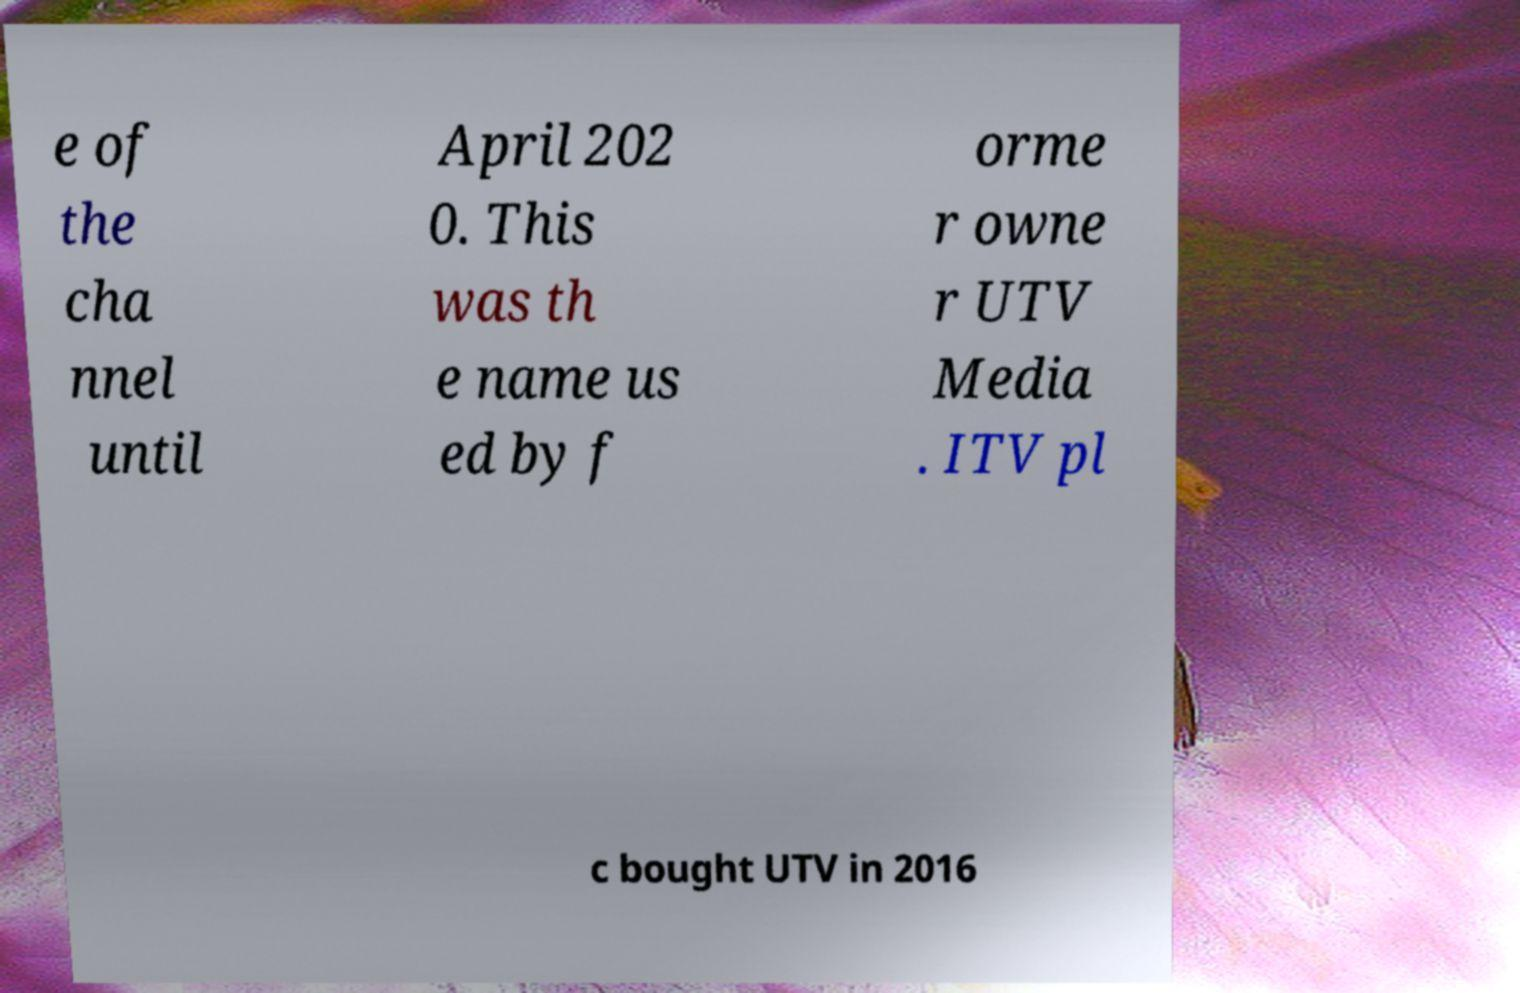Can you read and provide the text displayed in the image?This photo seems to have some interesting text. Can you extract and type it out for me? e of the cha nnel until April 202 0. This was th e name us ed by f orme r owne r UTV Media . ITV pl c bought UTV in 2016 